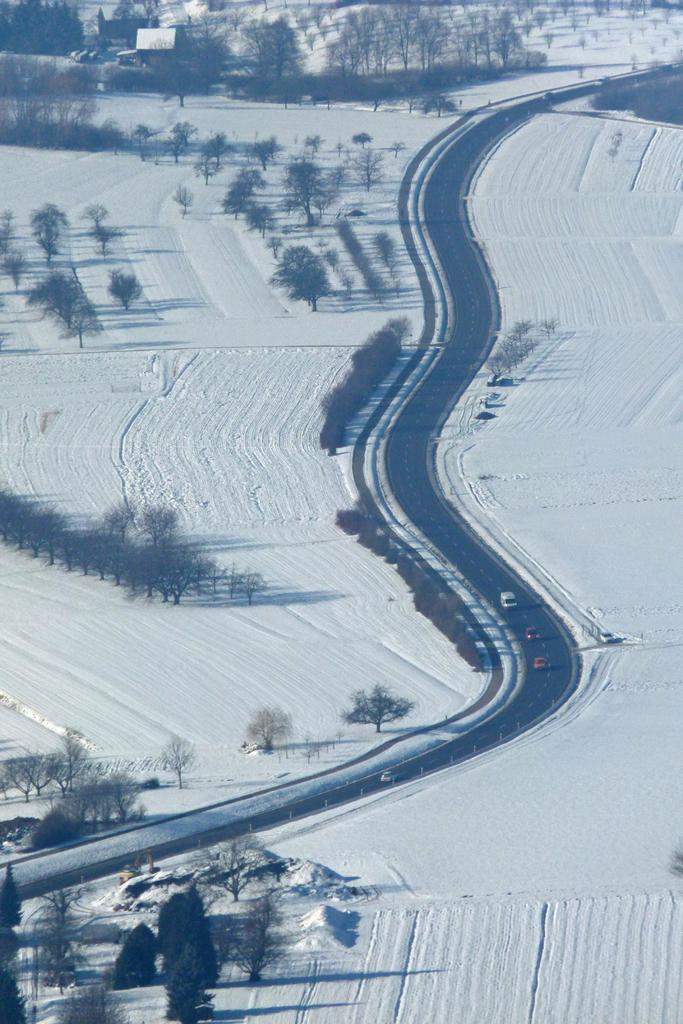What can be seen on the road in the image? There are vehicles on the road in the image. What type of natural elements are visible in the image? There are trees visible in the image. What is the color of the surface in the image? There is a white surface in the image. What type of thread is being used by the laborer in the image? There is no laborer or thread present in the image. What advice is being given by the person in the image? There is no person or advice present in the image. 